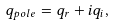Convert formula to latex. <formula><loc_0><loc_0><loc_500><loc_500>q _ { p o l e } = q _ { r } + i q _ { i } ,</formula> 